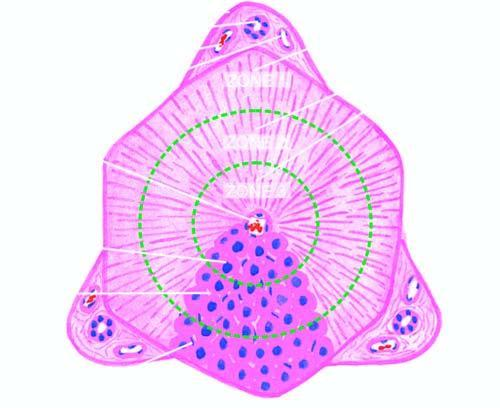how many zones are shown by circles?
Answer the question using a single word or phrase. 3 